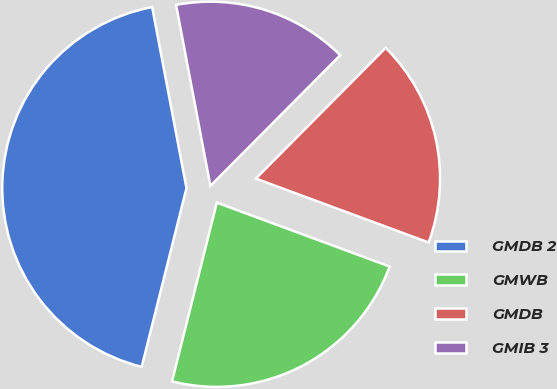Convert chart to OTSL. <chart><loc_0><loc_0><loc_500><loc_500><pie_chart><fcel>GMDB 2<fcel>GMWB<fcel>GMDB<fcel>GMIB 3<nl><fcel>43.11%<fcel>23.27%<fcel>18.19%<fcel>15.43%<nl></chart> 